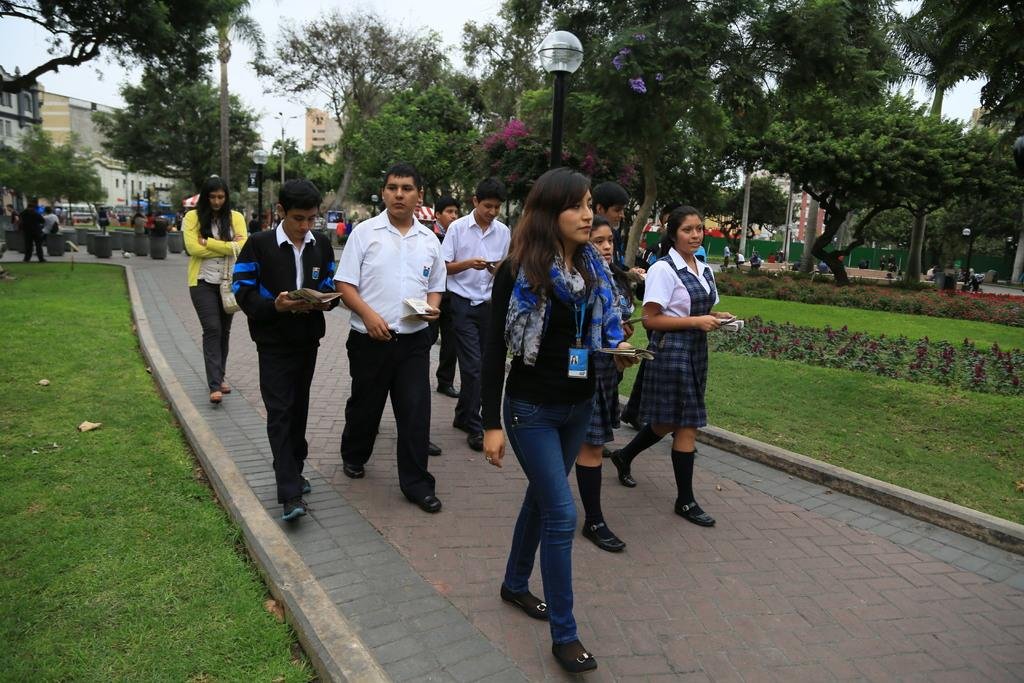What are the people in the image doing? There is a group of people walking in the image. On what surface are the people walking? The people are walking on a pavement. What type of vegetation can be seen in the image? There is grass and trees in the image. What type of structures are visible in the image? There are buildings in the image. What are the light sources in the image? There are light poles in the image. Can you see any fairies flying around the trees in the image? There are no fairies present in the image; it only shows a group of people walking on a pavement, surrounded by grass, trees, and buildings. 